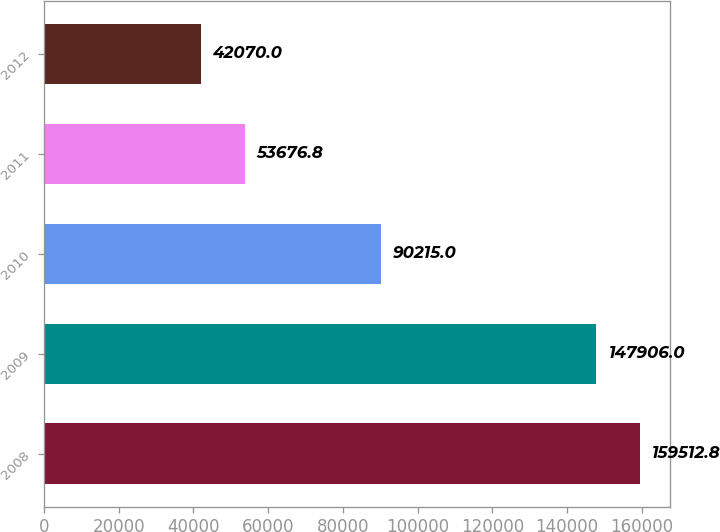Convert chart. <chart><loc_0><loc_0><loc_500><loc_500><bar_chart><fcel>2008<fcel>2009<fcel>2010<fcel>2011<fcel>2012<nl><fcel>159513<fcel>147906<fcel>90215<fcel>53676.8<fcel>42070<nl></chart> 